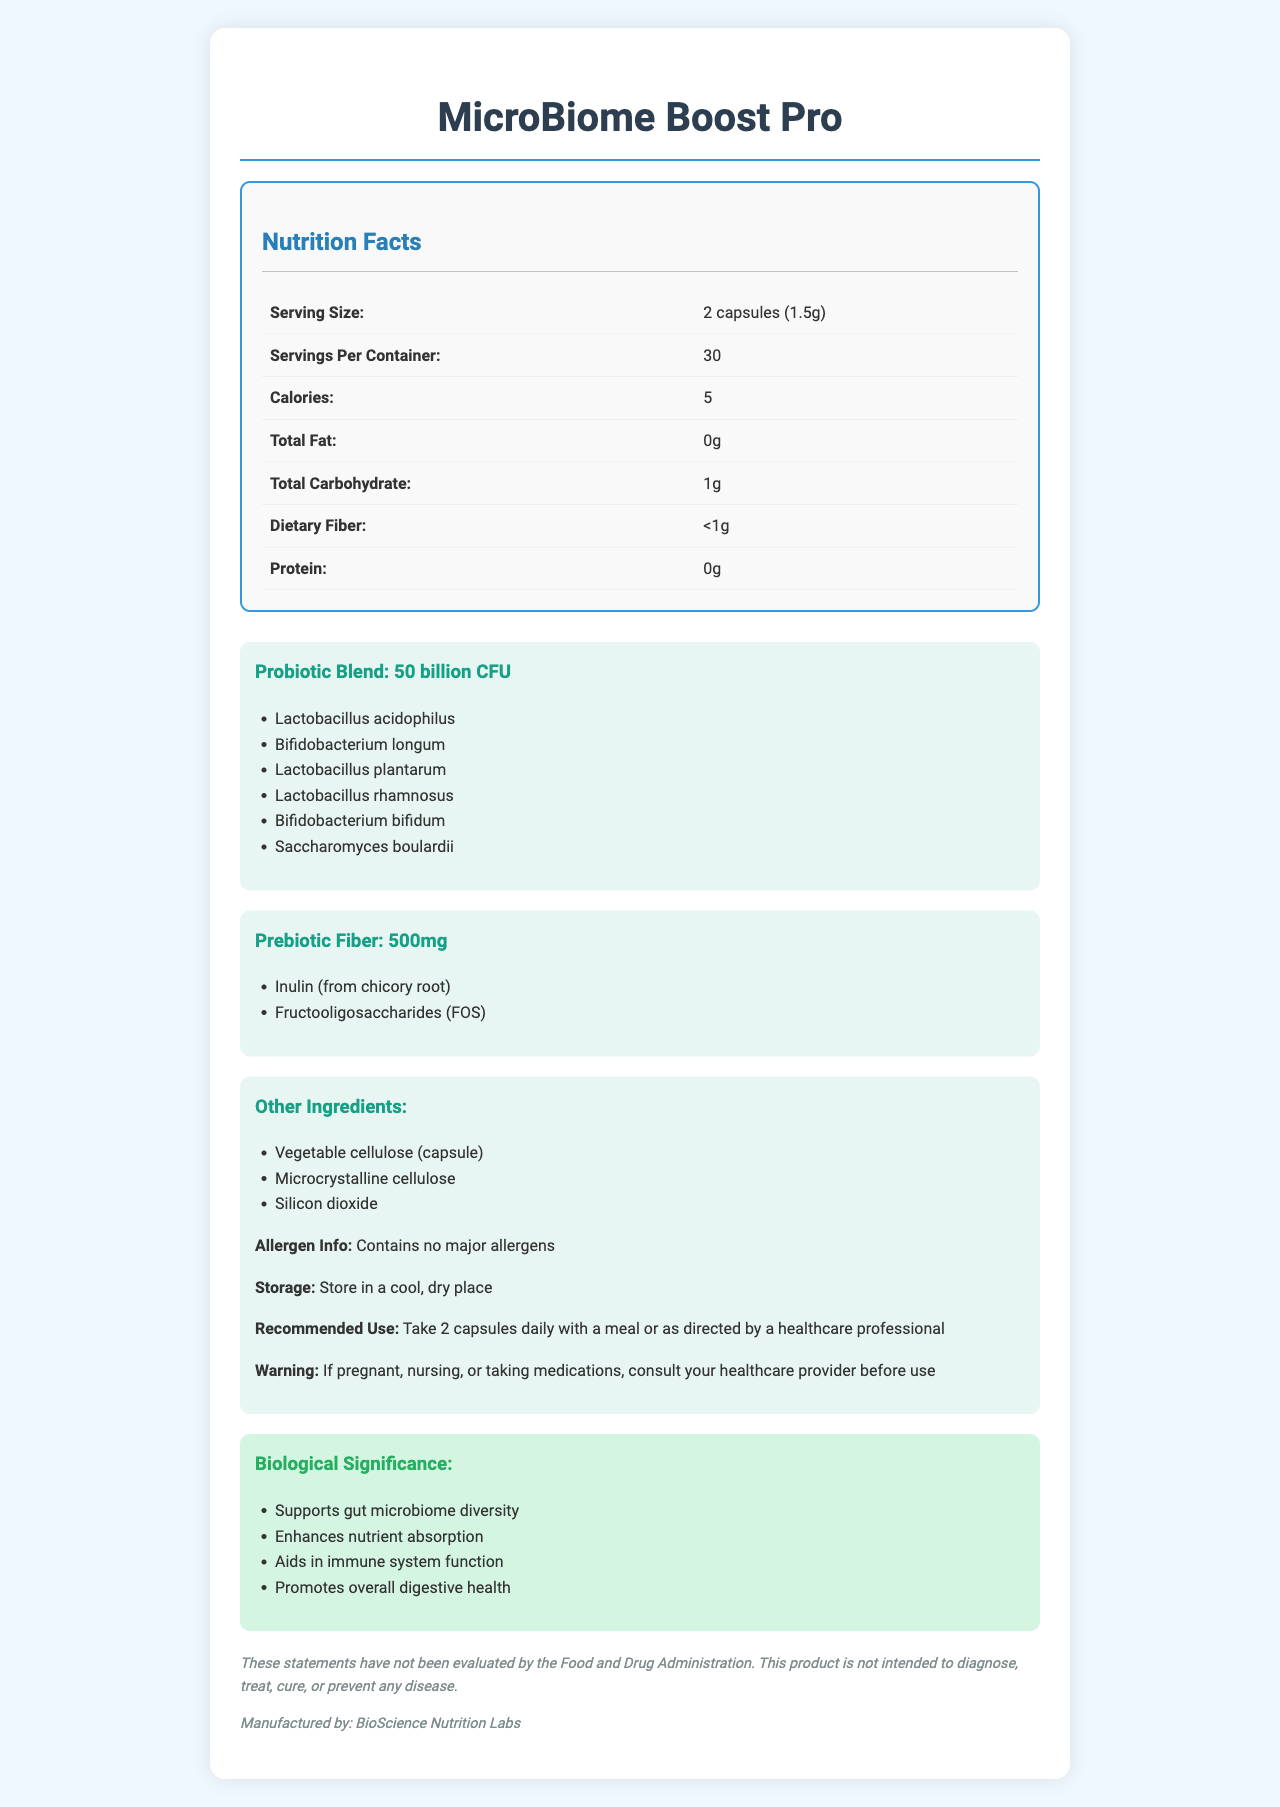what is the name of the product? The product name is clearly stated at the top of the document.
Answer: MicroBiome Boost Pro what is the serving size for this probiotic supplement? The serving size is specified in the Nutrition Facts section.
Answer: 2 capsules (1.5g) how many servings are there per container? The document states that there are 30 servings per container.
Answer: 30 how many probiotic strains are included in this supplement? The document lists six different probiotic strains under the Probiotic Blend section.
Answer: 6 what is the total amount of prebiotic fiber per serving? The prebiotic fiber amount is listed in the Prebiotic Fiber section.
Answer: 500mg what is the primary purpose of the probiotic strains in this supplement? A. Support gut microbiome diversity B. Improve skin health C. Enhance memory function D. Reduce joint pain The biological significance section mentions that the primary purpose is to support gut microbiome diversity.
Answer: A which of the following is NOT an ingredient in this supplement? 1. Vegetable cellulose 2. Microcrystalline cellulose 3. Silicon dioxide 4. Lactose Lactose is not listed as one of the ingredients in this supplement.
Answer: 4 does the product contain any major allergens? The allergen information explicitly states that the product contains no major allergens.
Answer: No describe the main biological benefits of this supplement. The document lists these points under the biological significance section, highlighting the main benefits of the product.
Answer: The supplement supports gut microbiome diversity, enhances nutrient absorption, aids in immune system function, and promotes overall digestive health. who manufactures this probiotic supplement? The manufacturing information provided at the end of the document indicates BioScience Nutrition Labs as the manufacturer.
Answer: BioScience Nutrition Labs how should this supplement be stored? The storage instructions specify that the supplement should be stored in a cool, dry place.
Answer: In a cool, dry place can this supplement diagnose, treat, cure, or prevent any disease? The disclaimer explicitly states that the supplement is not intended to diagnose, treat, cure, or prevent any disease.
Answer: No what are the two sources of prebiotic fiber in this supplement? These sources are listed in the prebiotic fiber section.
Answer: Inulin (from chicory root) and Fructooligosaccharides (FOS) what is the function of prebiotic fibers in this supplement? The scientific notes indicate that prebiotic fibers provide nourishment for beneficial gut bacteria.
Answer: They act as nourishment for beneficial gut bacteria. is it safe for pregnant women to take this supplement without consulting a healthcare provider? The warning advises that pregnant women should consult their healthcare provider before using the supplement.
Answer: No what is the main idea of this document? The document is focused on the nutritional information, ingredients, health benefits, and usage instructions for the supplement.
Answer: This document provides detailed nutrition facts, ingredients, and health benefits for the novel probiotic supplement "MicroBiome Boost Pro," which is designed to enhance gut microbiome diversity and overall digestive health. what specific research was conducted on the probiotic strains? The document mentions that the probiotic strains were selected based on extensive microbiome research but does not provide detail on the specific research conducted.
Answer: Cannot be determined 